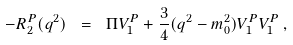<formula> <loc_0><loc_0><loc_500><loc_500>- R _ { 2 } ^ { P } ( q ^ { 2 } ) \ = \ \Pi V ^ { P } _ { 1 } + \frac { 3 } { 4 } ( q ^ { 2 } - m _ { 0 } ^ { 2 } ) V ^ { P } _ { 1 } V ^ { P } _ { 1 } \, ,</formula> 